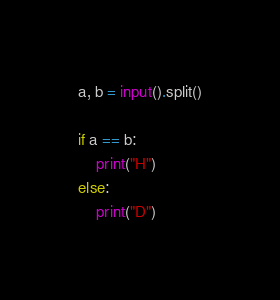<code> <loc_0><loc_0><loc_500><loc_500><_Python_>a, b = input().split()

if a == b:
    print("H")
else:
    print("D")
</code> 